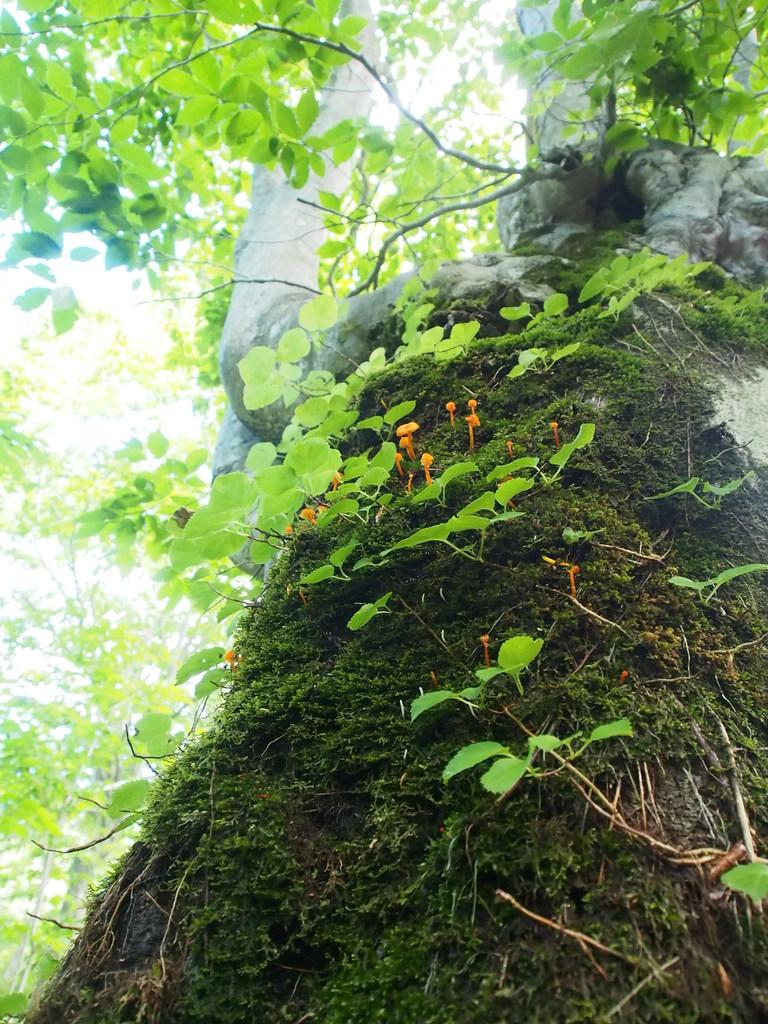What is the main subject in the center of the image? There is a tree in the center of the image. What type of wine is being offered during the lunch in the image? There is no wine or lunch depicted in the image; it only features a tree. 